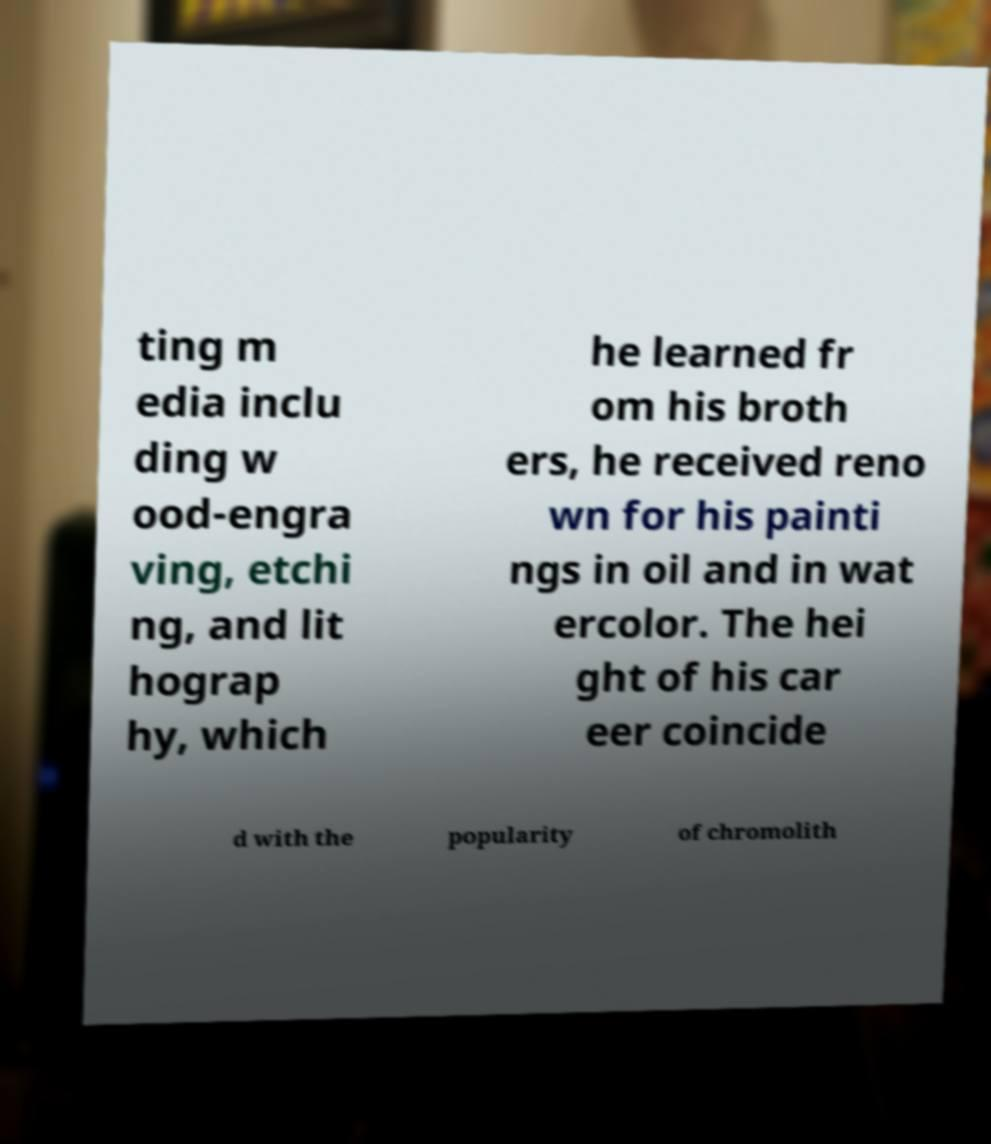Can you read and provide the text displayed in the image?This photo seems to have some interesting text. Can you extract and type it out for me? ting m edia inclu ding w ood-engra ving, etchi ng, and lit hograp hy, which he learned fr om his broth ers, he received reno wn for his painti ngs in oil and in wat ercolor. The hei ght of his car eer coincide d with the popularity of chromolith 